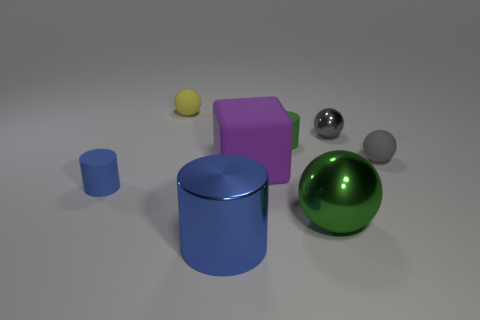What number of other things are there of the same color as the big metal cylinder?
Provide a succinct answer. 1. Are there any other things that have the same color as the tiny shiny thing?
Offer a very short reply. Yes. What is the material of the blue cylinder that is in front of the big metallic thing right of the metallic thing in front of the large green metallic ball?
Make the answer very short. Metal. Are there fewer gray shiny things than yellow metal things?
Offer a terse response. No. Does the big blue thing have the same material as the large purple cube?
Your response must be concise. No. What is the shape of the tiny matte object that is the same color as the large sphere?
Your answer should be very brief. Cylinder. There is a tiny matte cylinder in front of the small gray matte object; is it the same color as the rubber cube?
Give a very brief answer. No. How many yellow rubber balls are to the left of the tiny thing in front of the big rubber object?
Make the answer very short. 0. There is a metallic ball that is the same size as the purple matte cube; what is its color?
Provide a short and direct response. Green. There is a small sphere that is to the left of the small gray metallic sphere; what is its material?
Provide a succinct answer. Rubber. 